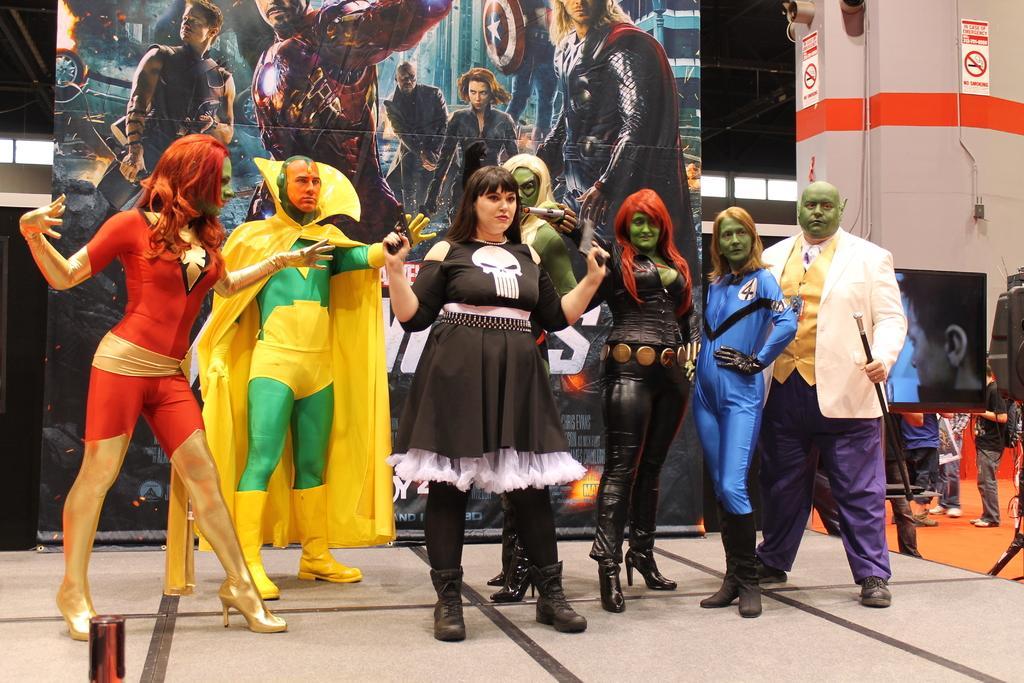In one or two sentences, can you explain what this image depicts? In this picture I can observe some people standing on the stage. They are wearing costumes. In the background I can observe a poster. On the right side I can observe a screen. There are some people standing on the floor. 